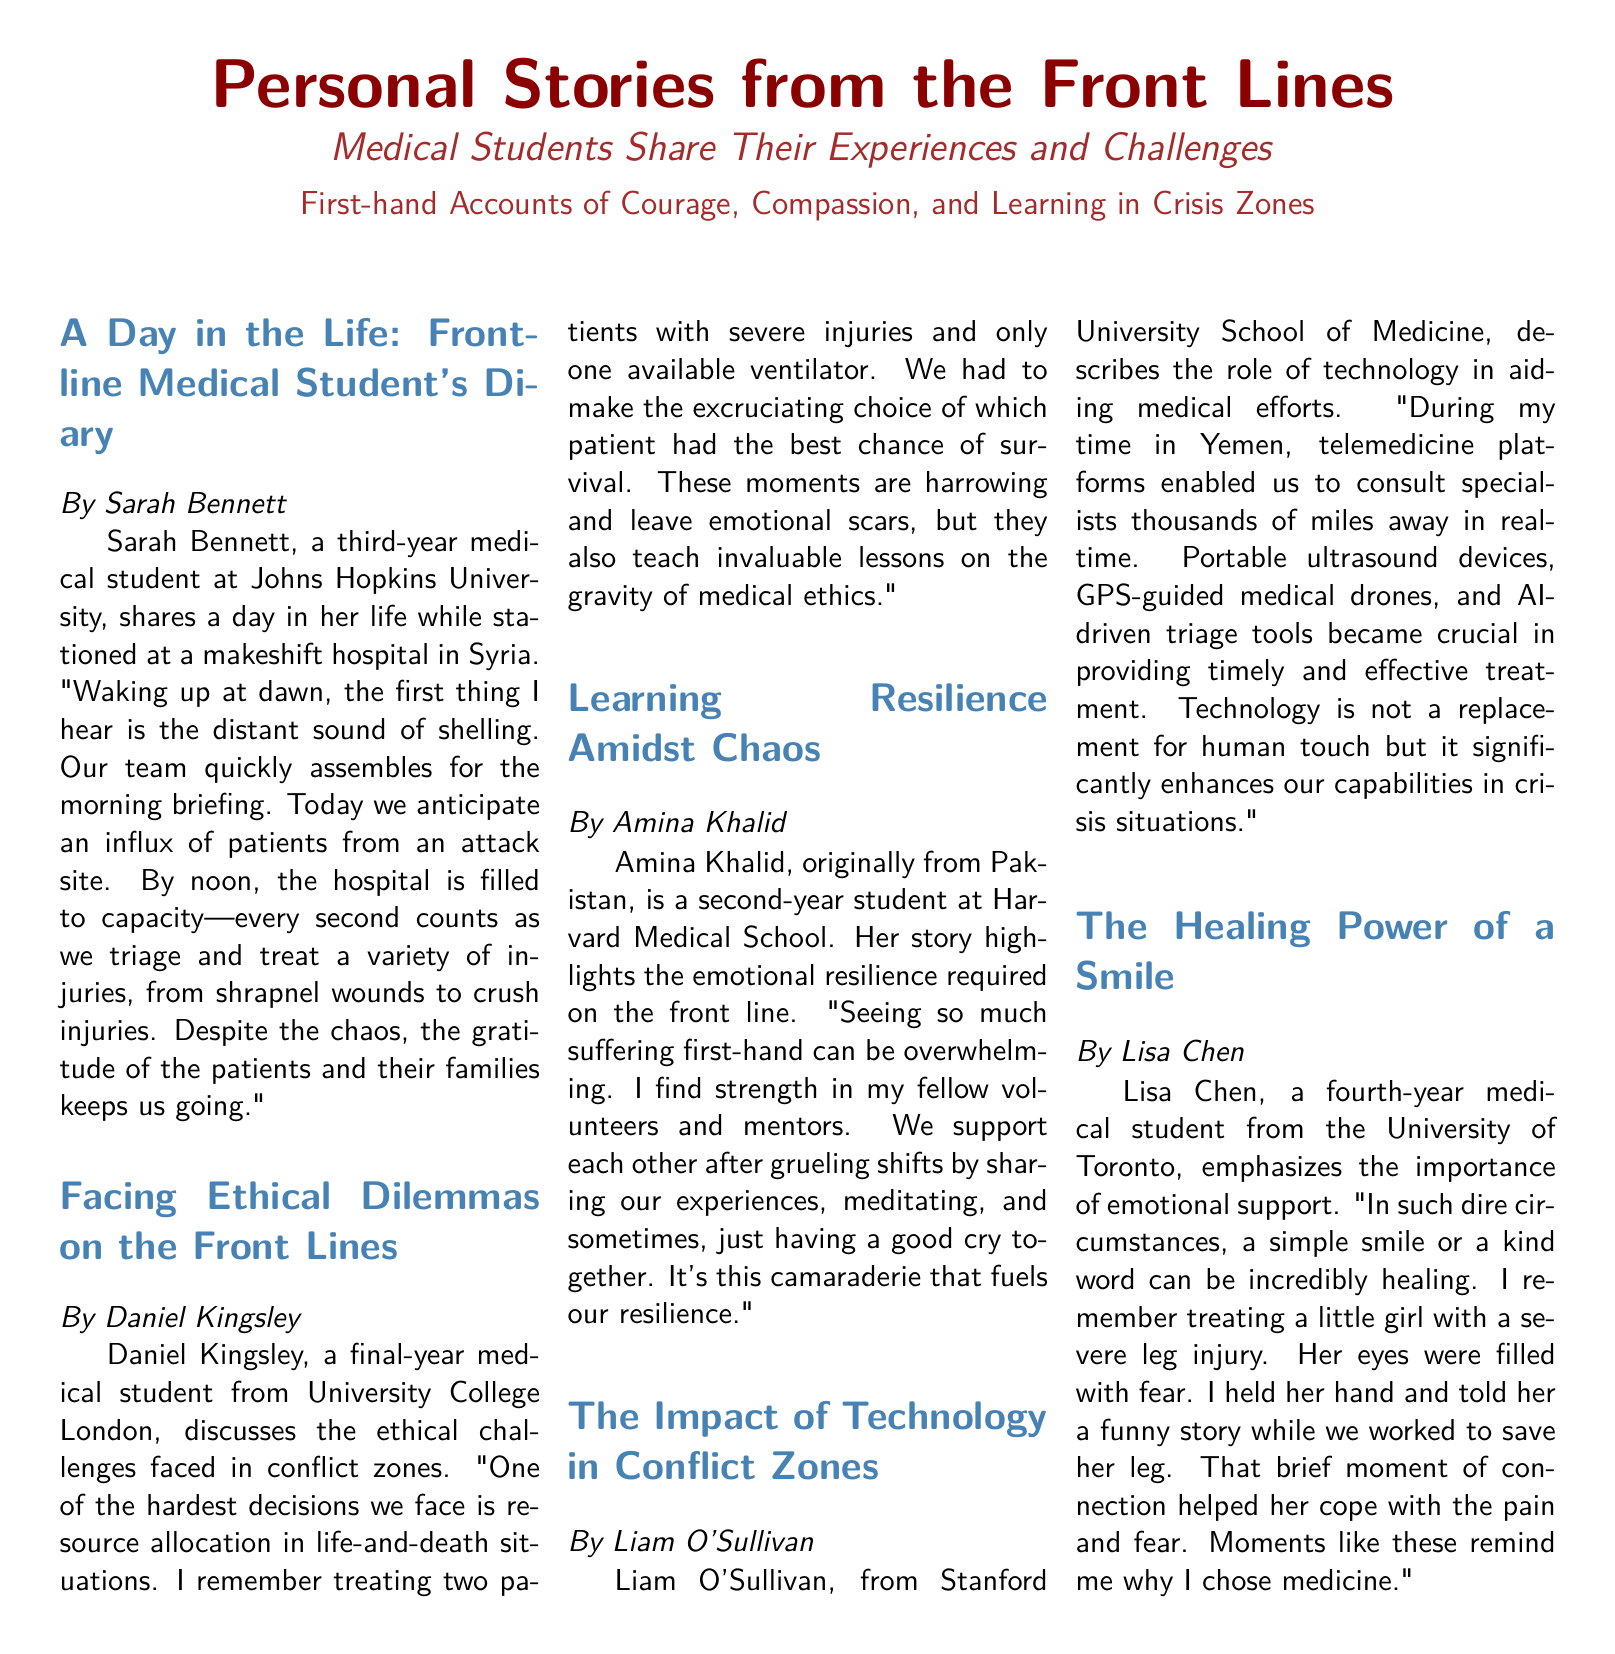What is the name of the medical student who wrote about her experiences in Syria? Sarah Bennett shares her experiences while stationed at a makeshift hospital in Syria.
Answer: Sarah Bennett Which university is Daniel Kingsley affiliated with? The document states that Daniel Kingsley is a final-year medical student from University College London.
Answer: University College London What technology did Liam O'Sullivan mention as enhancing medical capabilities? Liam O'Sullivan describes telemedicine platforms, portable ultrasound devices, GPS-guided drones, and AI-driven triage tools as significant during his time in Yemen.
Answer: Technology What emotional support activity did Amina Khalid mention after grueling shifts? Amina Khalid indicates that sharing experiences and meditating helps in fostering emotional resilience.
Answer: Sharing experiences What healing gesture did Lisa Chen emphasize during her treatment of a young patient? Lisa Chen mentions that a simple smile or kind word can be incredibly healing in dire circumstances.
Answer: Smile How many medical students shared their experiences in the document? The document includes five accounts from different medical students about their experiences and challenges.
Answer: Five 